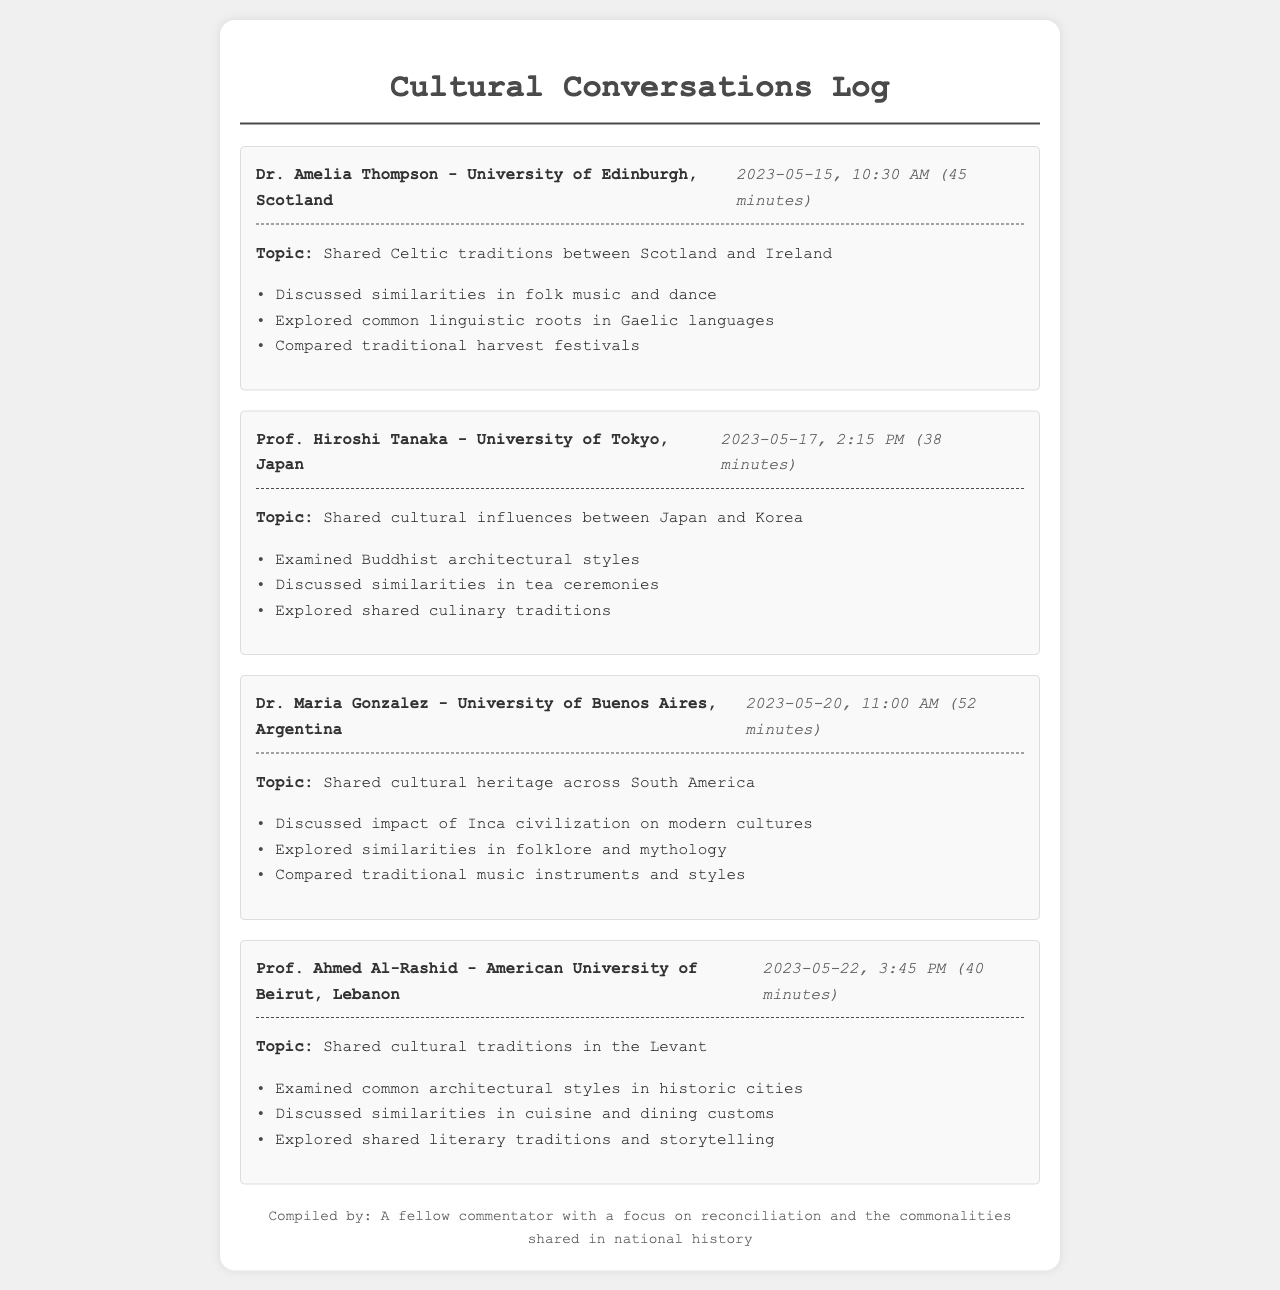What is the topic of the call with Dr. Amelia Thompson? The topic indicated in the call log is "Shared Celtic traditions between Scotland and Ireland."
Answer: Shared Celtic traditions between Scotland and Ireland What is the duration of the call with Prof. Hiroshi Tanaka? The call log states that the call lasted 38 minutes.
Answer: 38 minutes Who discussed cultural heritage across South America? According to the document, the person who discussed this topic was Dr. Maria Gonzalez.
Answer: Dr. Maria Gonzalez What date did the call with Prof. Ahmed Al-Rashid take place? The call took place on May 22, 2023, as mentioned in the call log.
Answer: May 22, 2023 What architectural styles were examined in the call with Prof. Hiroshi Tanaka? The call log notes the examination of "Buddhist architectural styles."
Answer: Buddhist architectural styles How many key points were discussed in the call with Dr. Maria Gonzalez? The call log lists three key points discussed during this call.
Answer: Three Which university is Dr. Amelia Thompson affiliated with? The document mentions that Dr. Amelia Thompson is with the University of Edinburgh.
Answer: University of Edinburgh What shared tradition was explored in the call with Prof. Ahmed Al-Rashid? The call log indicates that shared literary traditions and storytelling were explored.
Answer: Shared literary traditions and storytelling 